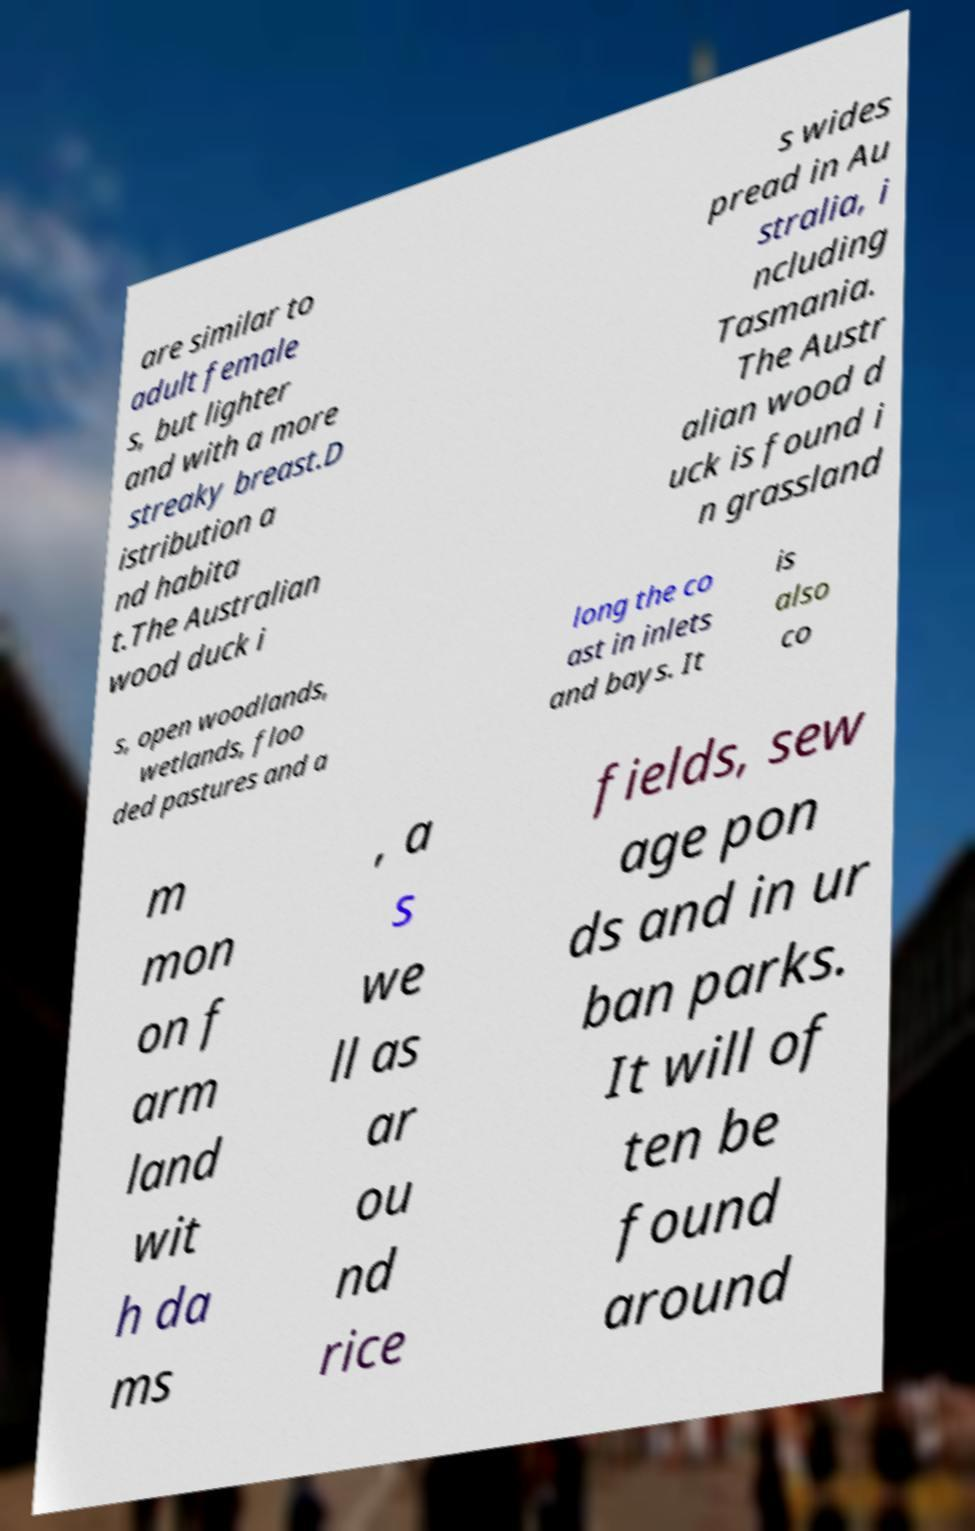Can you accurately transcribe the text from the provided image for me? are similar to adult female s, but lighter and with a more streaky breast.D istribution a nd habita t.The Australian wood duck i s wides pread in Au stralia, i ncluding Tasmania. The Austr alian wood d uck is found i n grassland s, open woodlands, wetlands, floo ded pastures and a long the co ast in inlets and bays. It is also co m mon on f arm land wit h da ms , a s we ll as ar ou nd rice fields, sew age pon ds and in ur ban parks. It will of ten be found around 